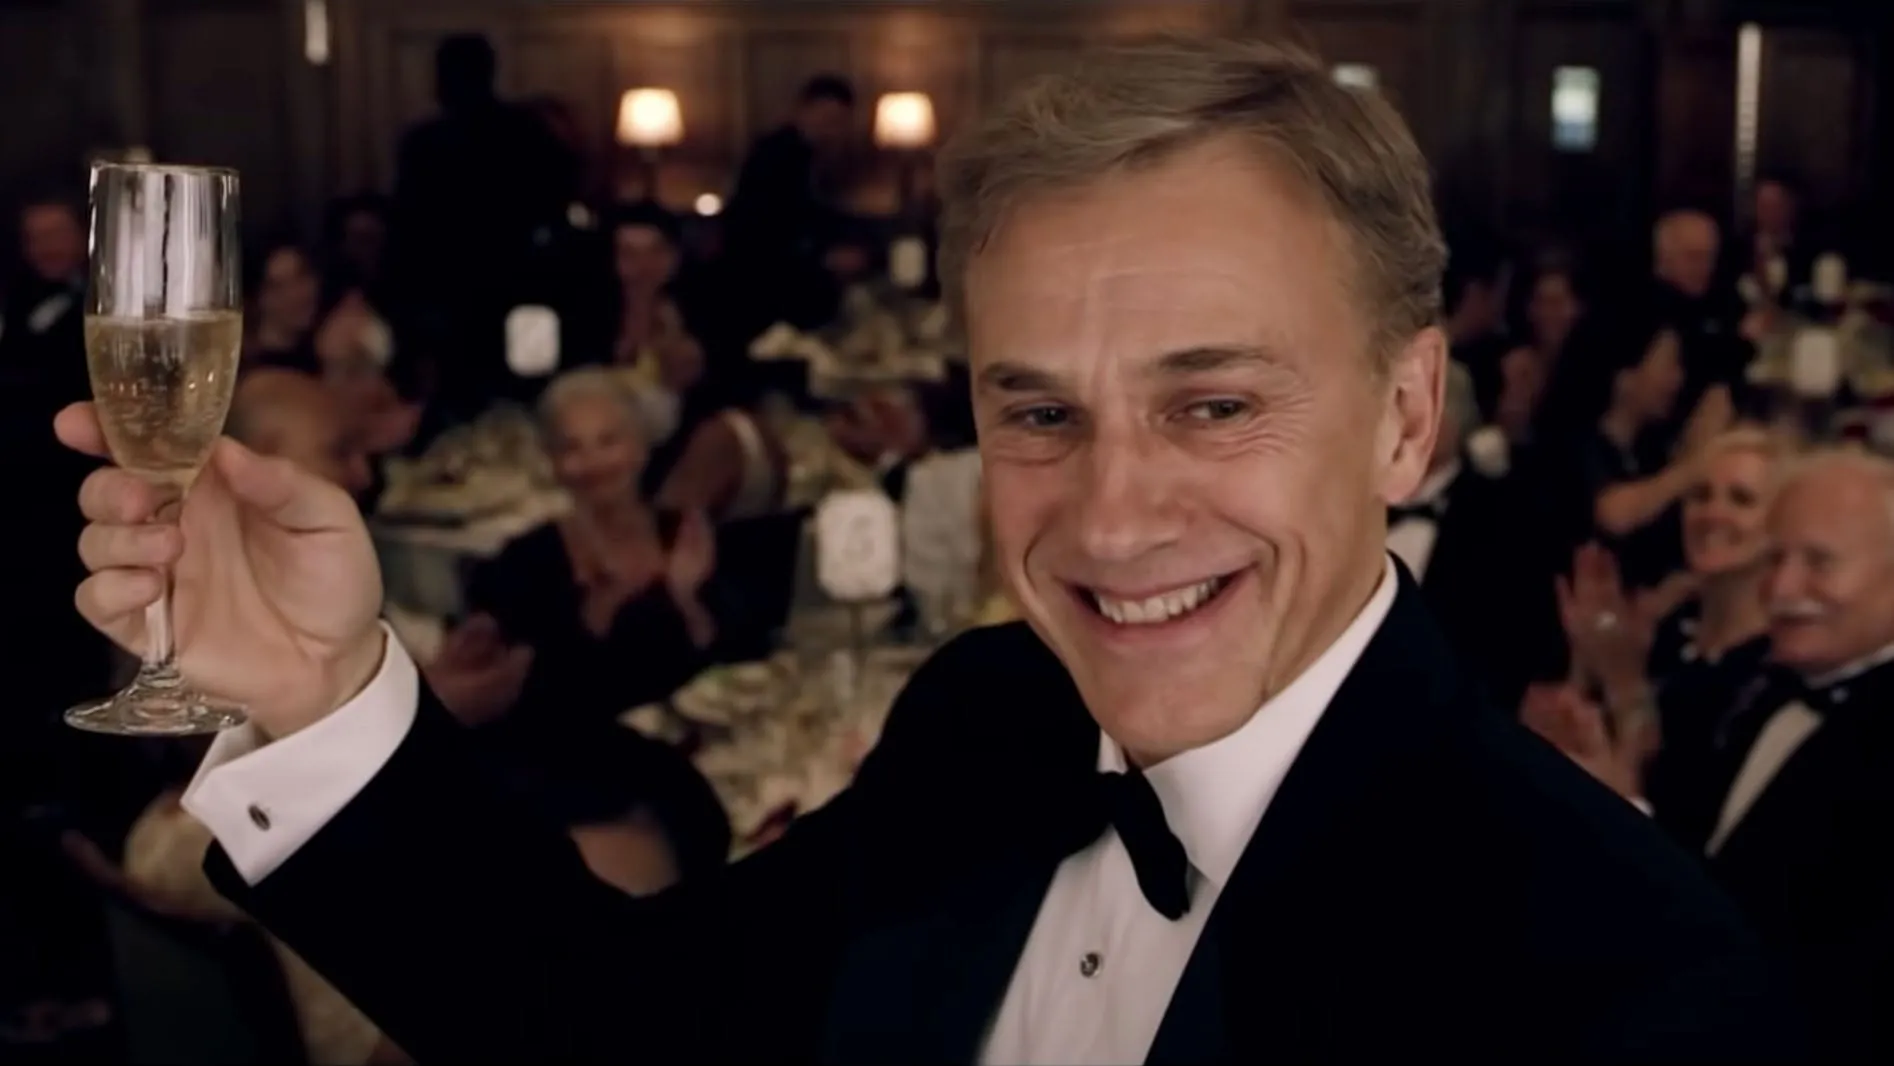Imagine a completely different setting for this celebration. Imagine this celebration taking place on a luxurious yacht cruising through pristine turquoise waters. The guests are dressed in elegant summer attire, with the gentleman in the tuxedo now donning a crisp white suit. The deck is adorned with fairy lights and tropical flowers, creating a festive and exotic ambiance. As the sun sets, painting the sky in hues of orange and pink, the gentleman raises his glass in a toast, with the tranquil sound of the ocean waves enhancing the serene and joyful atmosphere around them. 